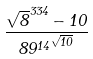<formula> <loc_0><loc_0><loc_500><loc_500>\frac { \sqrt { 8 } ^ { 3 3 4 } - 1 0 } { { 8 9 ^ { 1 4 } } ^ { \sqrt { 1 0 } } }</formula> 